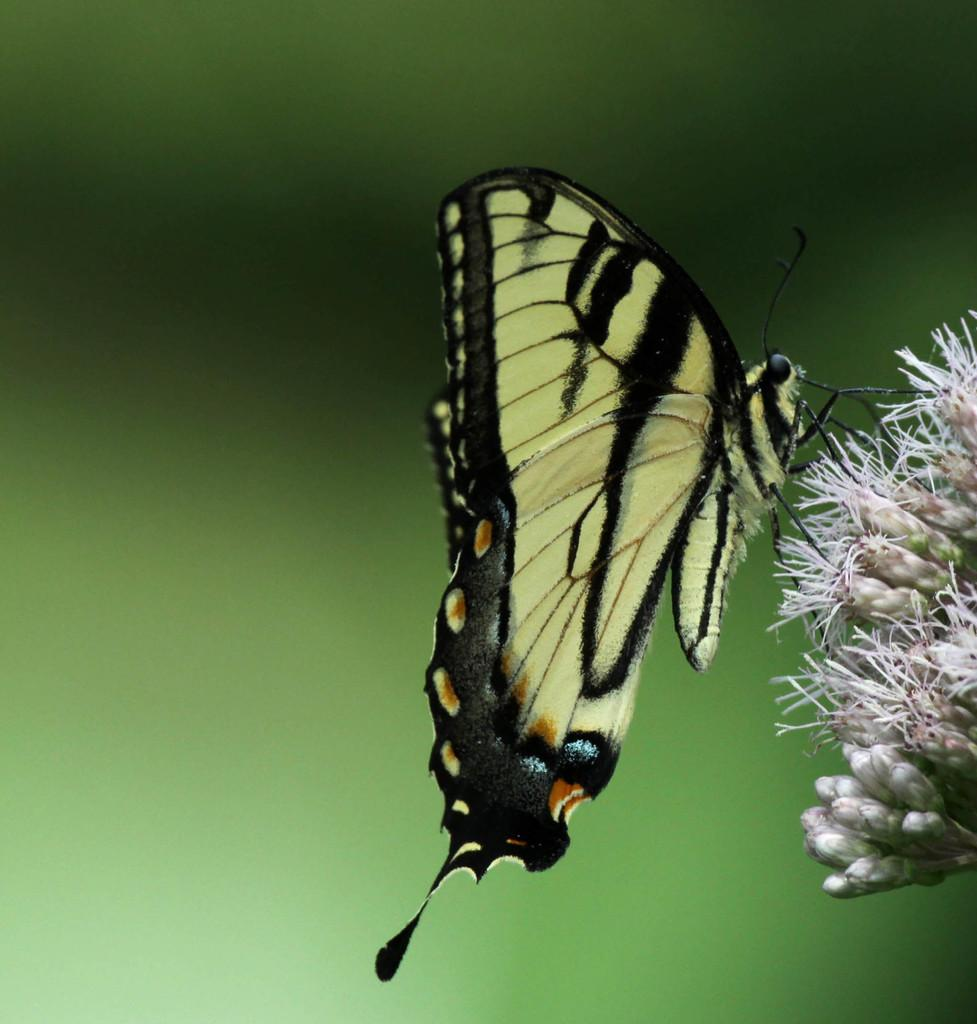What is the main subject of the image? There is a butterfly in the image. Where is the butterfly located? The butterfly is on a flower. Can you describe the background of the image? The background of the image is blurred. What color is the servant's uniform in the image? There is no servant present in the image, so it is not possible to determine the color of their uniform. 